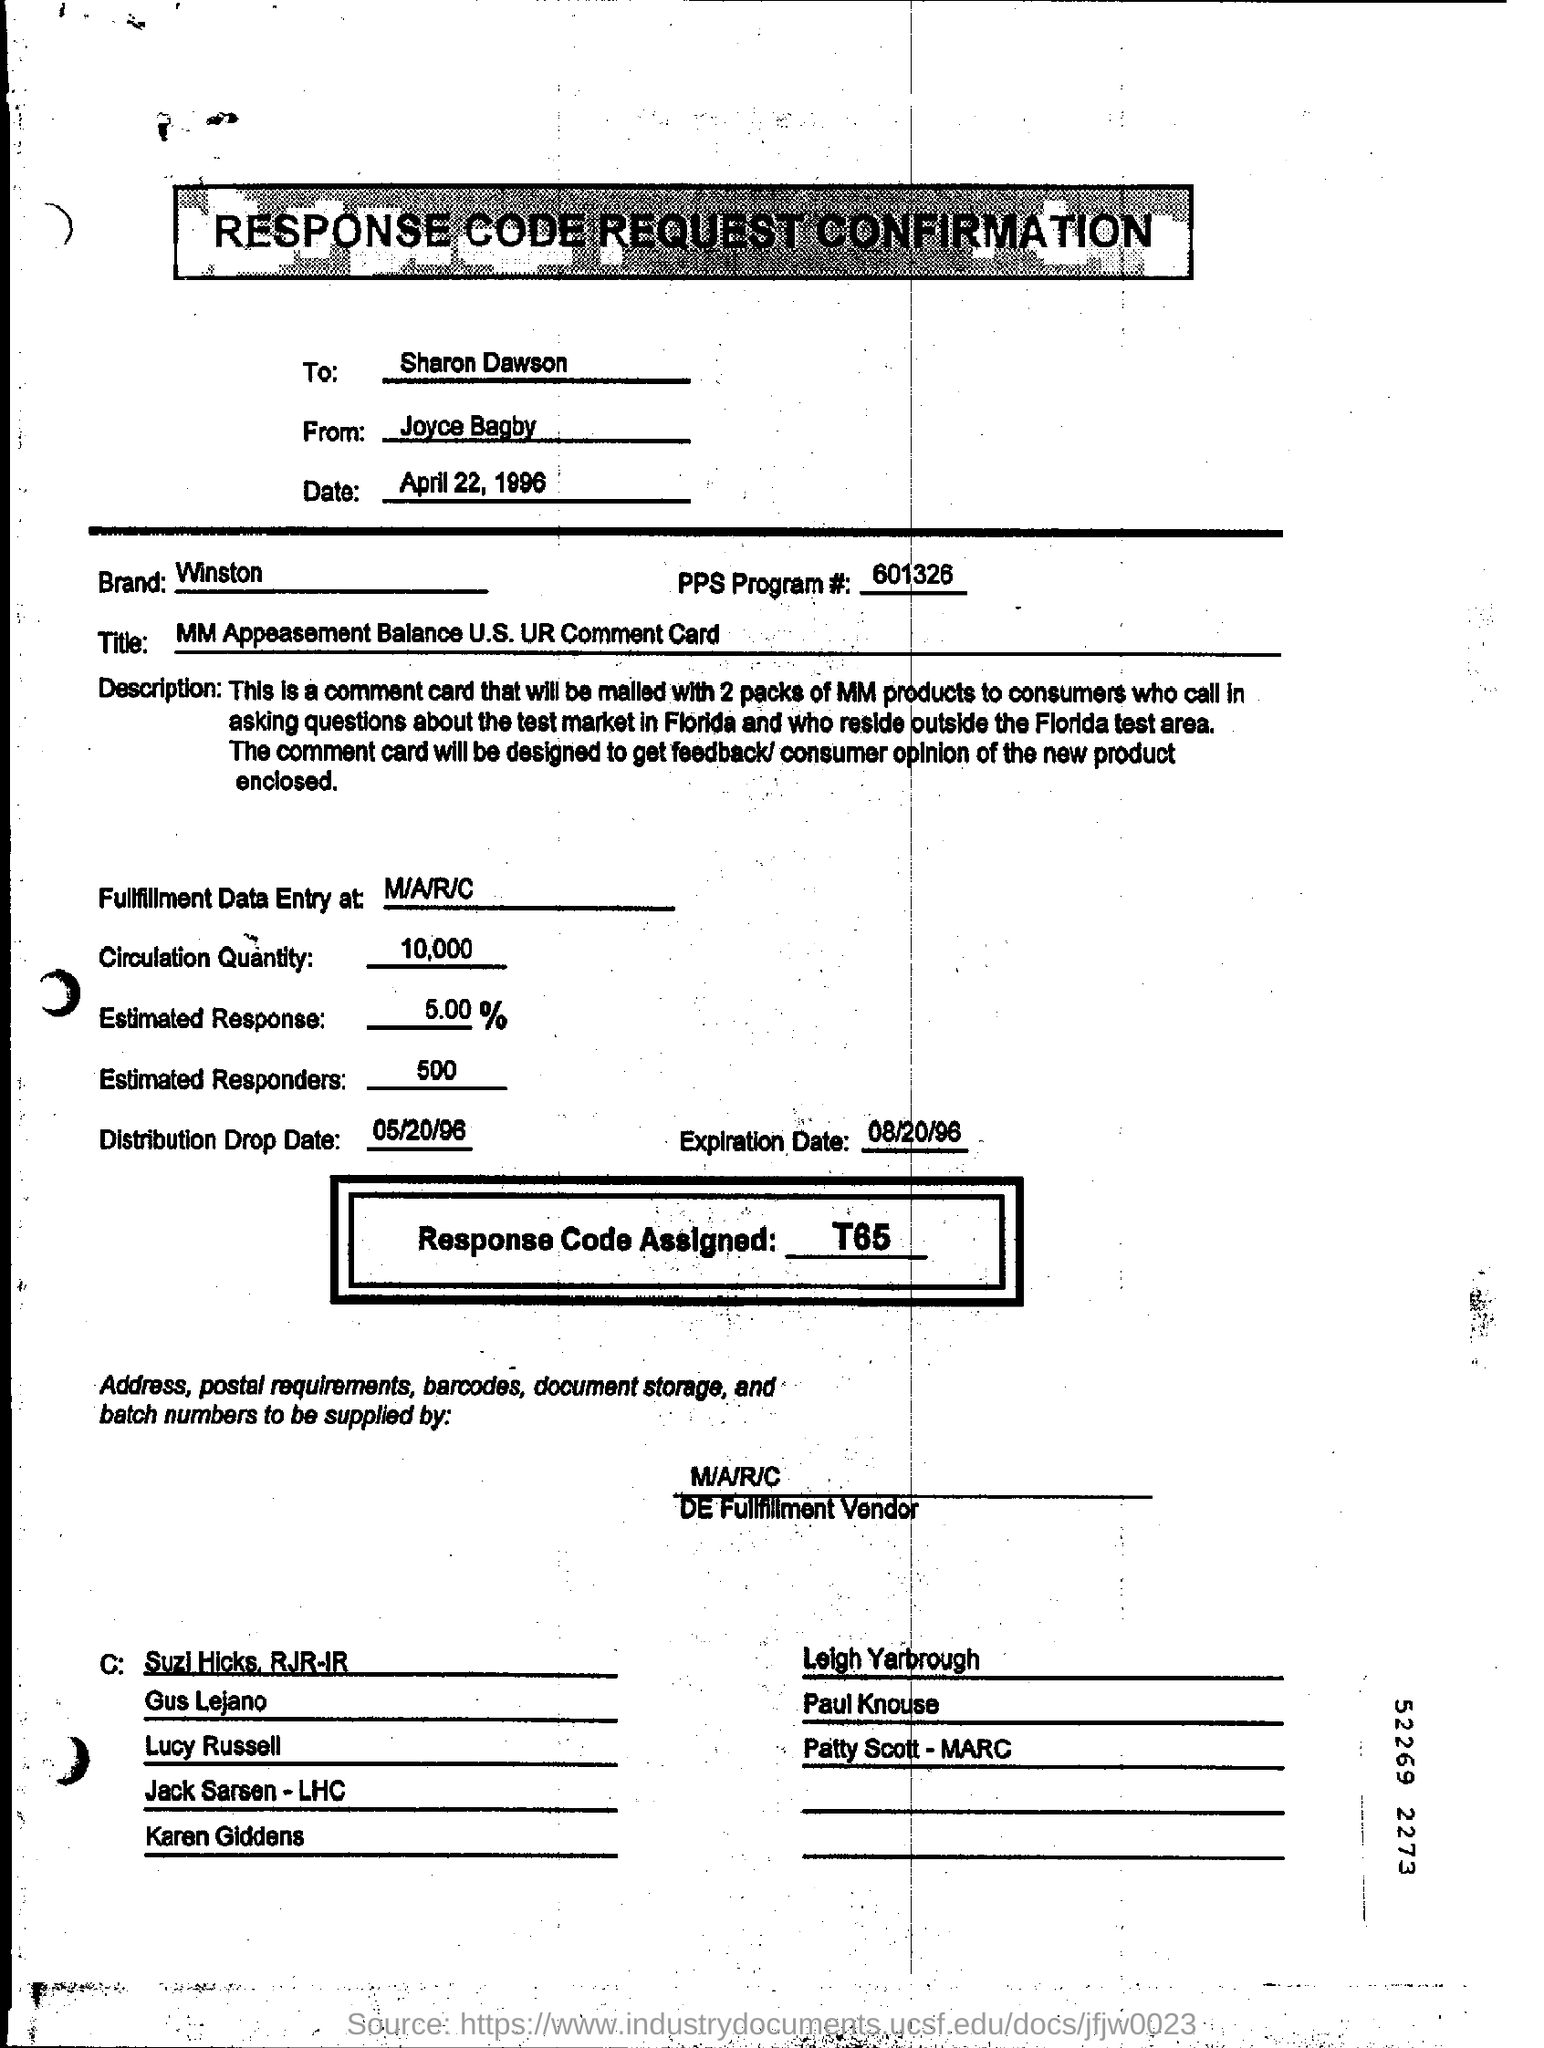Indicate a few pertinent items in this graphic. The assigned response code is T65.. The envelope is addressed to Sharon Dawson. The distribution drop date is May 20th, 1996. The PPs Program number is 601326... The date being referred to is April 22, 1996. 